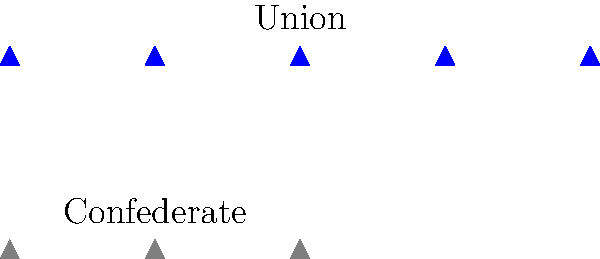Based on the scaled representation of soldiers in the image, what was the approximate ratio of Union to Confederate forces during the Civil War? To determine the ratio of Union to Confederate forces, we need to follow these steps:

1. Count the number of Union soldiers (blue icons):
   There are 5 blue soldier icons.

2. Count the number of Confederate soldiers (gray icons):
   There are 3 gray soldier icons.

3. Express the ratio of Union to Confederate soldiers:
   Union : Confederate = 5 : 3

4. Simplify the ratio:
   The ratio 5:3 is already in its simplest form.

5. Convert the ratio to a fraction:
   $\frac{5}{3}$

Therefore, based on this scaled representation, the approximate ratio of Union to Confederate forces during the Civil War was 5:3 or $\frac{5}{3}$.
Answer: 5:3 